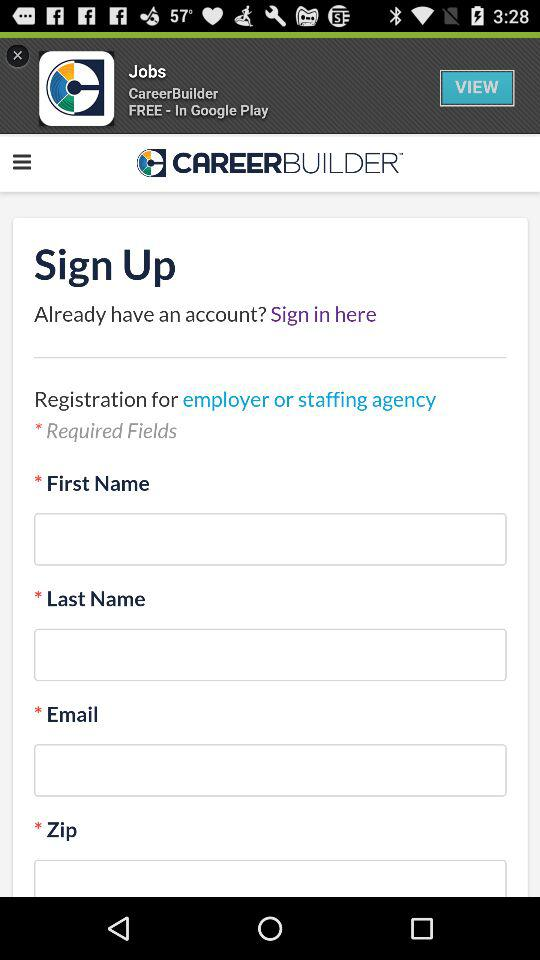How many fields are required?
Answer the question using a single word or phrase. 4 